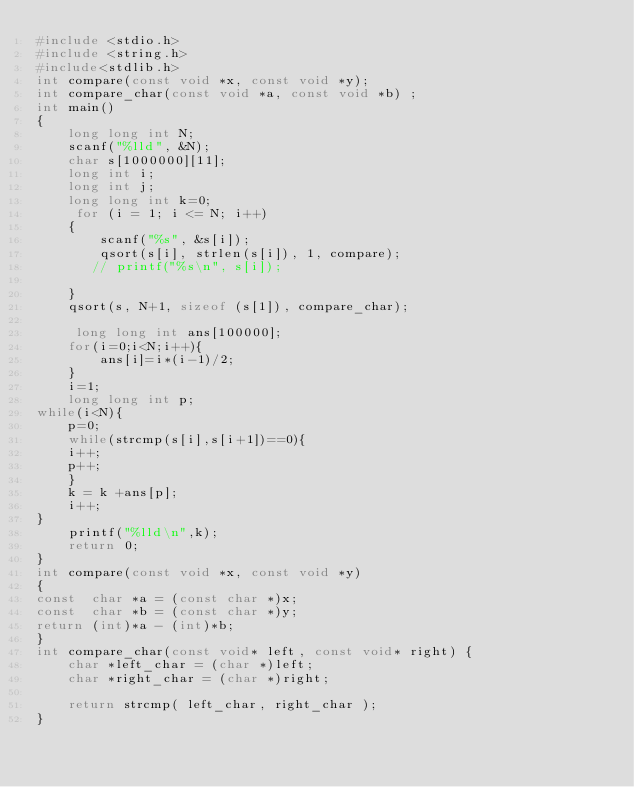<code> <loc_0><loc_0><loc_500><loc_500><_C_>#include <stdio.h>
#include <string.h>
#include<stdlib.h>
int compare(const void *x, const void *y);
int compare_char(const void *a, const void *b) ;
int main()
{
    long long int N;
    scanf("%lld", &N);
    char s[1000000][11];
    long int i;
    long int j;
    long long int k=0;
     for (i = 1; i <= N; i++)
    {
        scanf("%s", &s[i]);
        qsort(s[i], strlen(s[i]), 1, compare);
       // printf("%s\n", s[i]);

    }
    qsort(s, N+1, sizeof (s[1]), compare_char); 

     long long int ans[100000];
    for(i=0;i<N;i++){
        ans[i]=i*(i-1)/2;
    }
    i=1;
    long long int p;
while(i<N){
    p=0;
    while(strcmp(s[i],s[i+1])==0){
    i++;
    p++;
    }
    k = k +ans[p];
    i++;
} 
    printf("%lld\n",k);
    return 0;
}
int compare(const void *x, const void *y)
{
const  char *a = (const char *)x;
const  char *b = (const char *)y;
return (int)*a - (int)*b;
}
int compare_char(const void* left, const void* right) {
    char *left_char = (char *)left;
    char *right_char = (char *)right;

    return strcmp( left_char, right_char );
}
</code> 